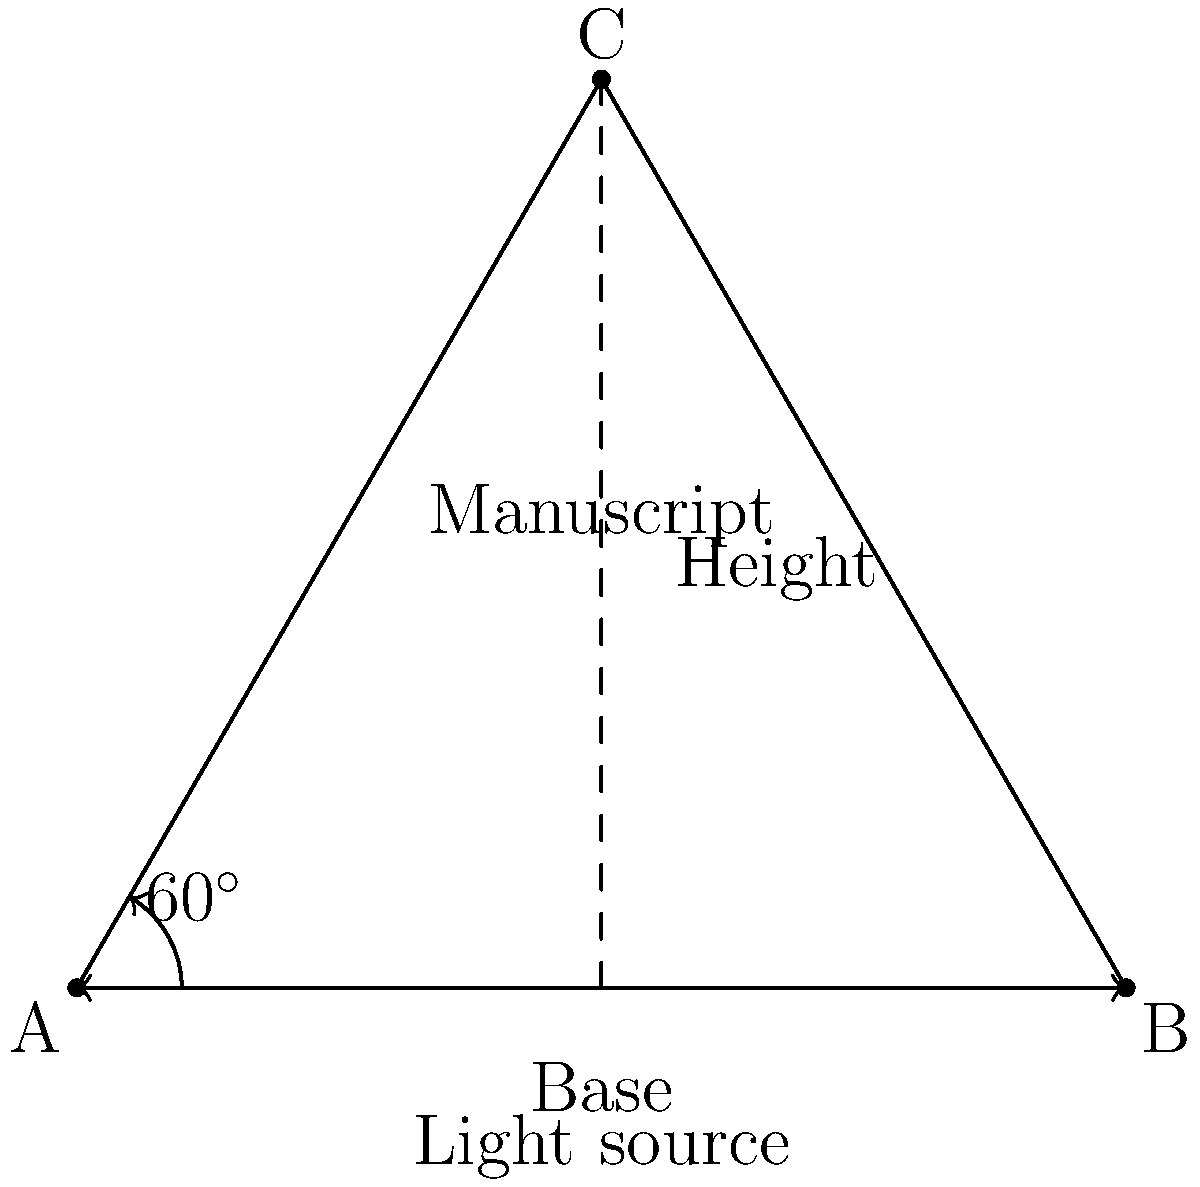As an art historian specializing in manuscripts, you're tasked with determining the optimal angle for displaying an open manuscript to minimize light exposure. Given that the light source is directly above the center of the manuscript, and the manuscript forms an equilateral triangle when open, what angle should the manuscript be opened to in order to minimize direct light exposure on its pages? To solve this problem, we need to consider the properties of an equilateral triangle and how light interacts with surfaces:

1) In an equilateral triangle, all angles are 60°.

2) Light exposure is minimized when the surface is perpendicular to the light source.

3) In this case, we want to find the angle that makes the manuscript pages as close to perpendicular to the light source as possible.

4) The angle between the manuscript page and the base (horizontal plane) is complementary to the angle at the base of the triangle.

5) In an equilateral triangle, the base angle is 60°.

6) Therefore, the angle between the manuscript page and the horizontal plane is:
   $90° - 60° = 30°$

7) This means that when the manuscript is opened to form a 60° angle (forming an equilateral triangle), each page will be at a 30° angle to the horizontal.

8) A 30° angle to the horizontal means a 60° angle to the vertical, which is as close to perpendicular (90°) as possible while maintaining the equilateral triangle shape.

Thus, opening the manuscript to a 60° angle (forming an equilateral triangle) provides the optimal balance between display and light exposure minimization.
Answer: 60° 